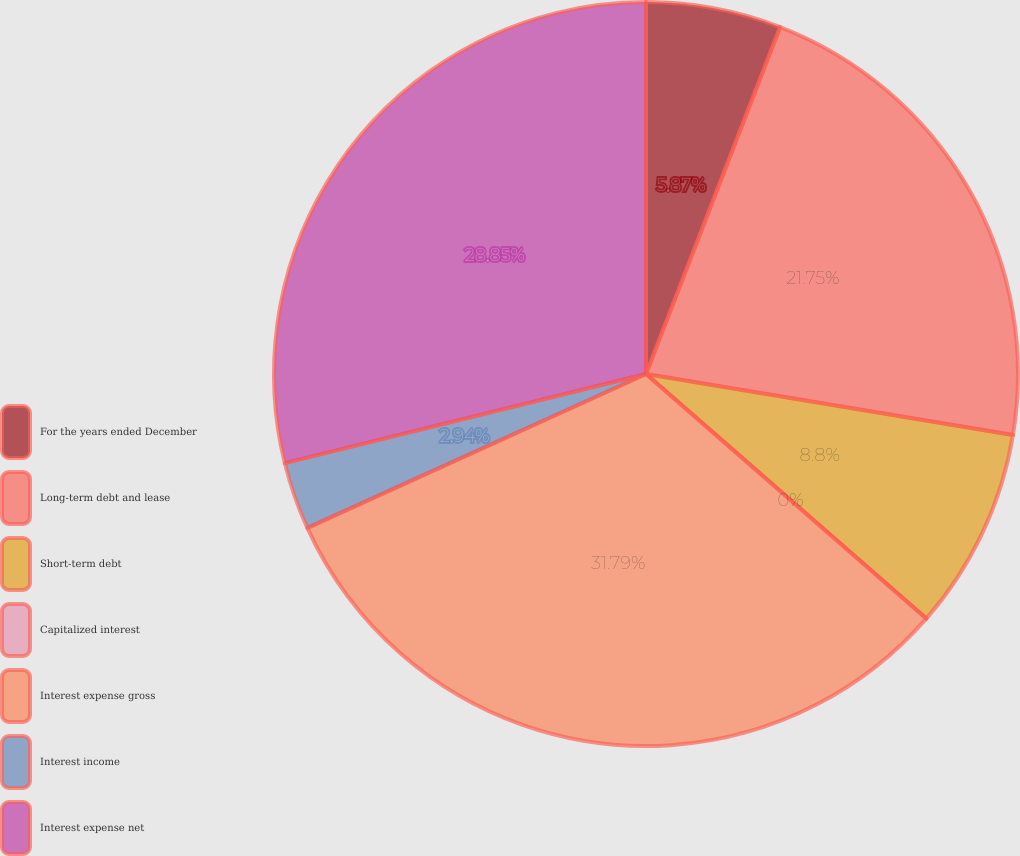Convert chart to OTSL. <chart><loc_0><loc_0><loc_500><loc_500><pie_chart><fcel>For the years ended December<fcel>Long-term debt and lease<fcel>Short-term debt<fcel>Capitalized interest<fcel>Interest expense gross<fcel>Interest income<fcel>Interest expense net<nl><fcel>5.87%<fcel>21.75%<fcel>8.8%<fcel>0.0%<fcel>31.79%<fcel>2.94%<fcel>28.85%<nl></chart> 